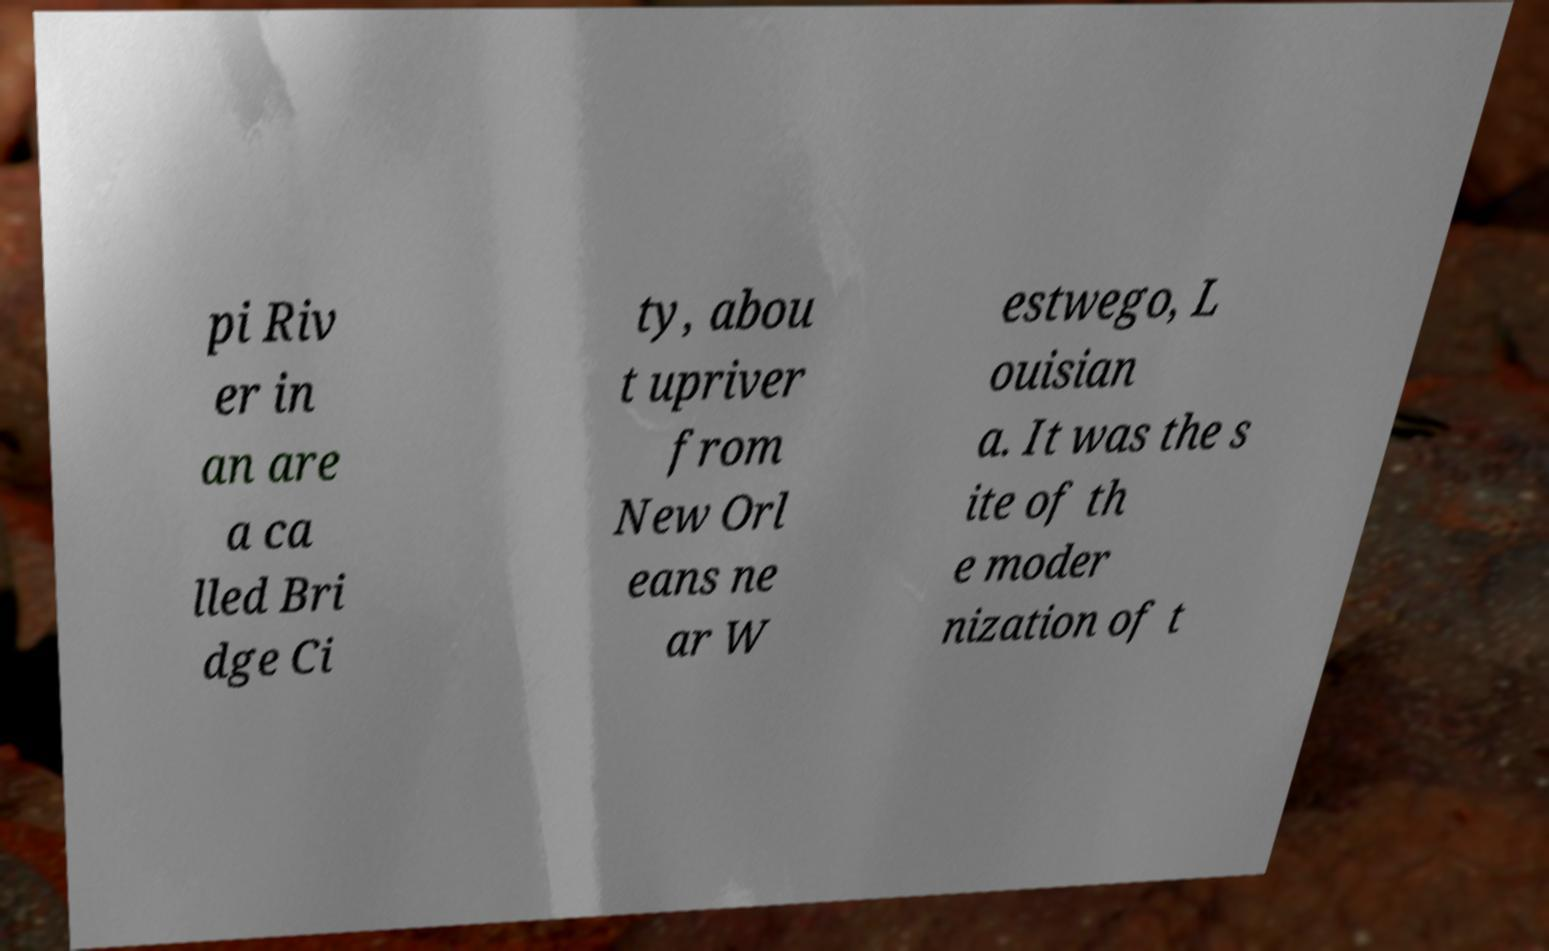What messages or text are displayed in this image? I need them in a readable, typed format. pi Riv er in an are a ca lled Bri dge Ci ty, abou t upriver from New Orl eans ne ar W estwego, L ouisian a. It was the s ite of th e moder nization of t 